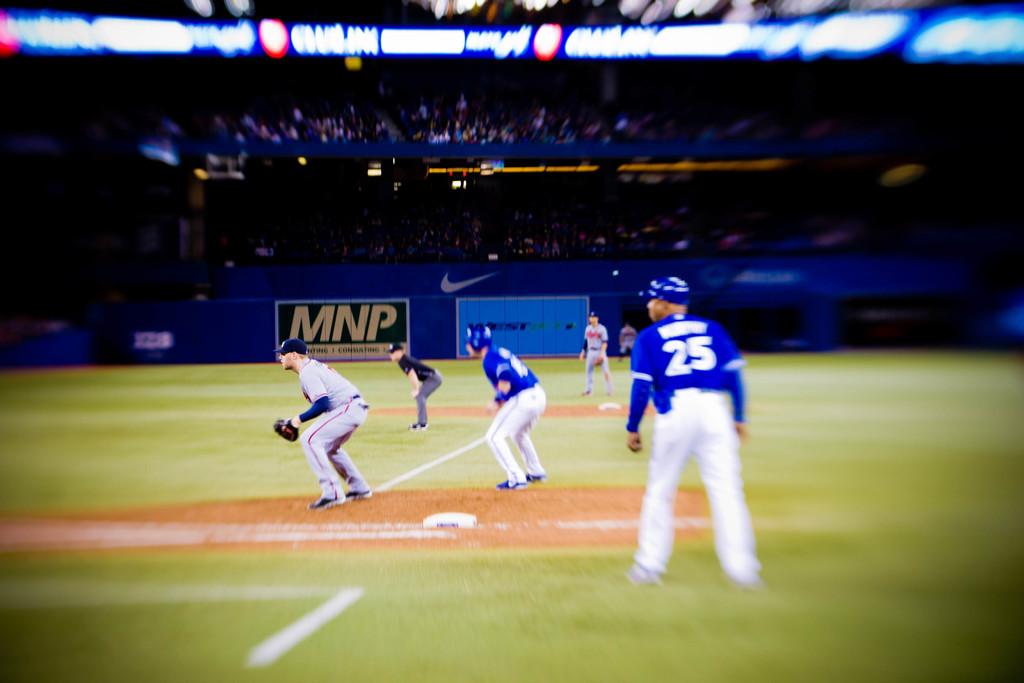What number of the guy in blue?
Provide a short and direct response. 25. What is the 3 letters in yellow in the back?
Provide a succinct answer. Mnp. 